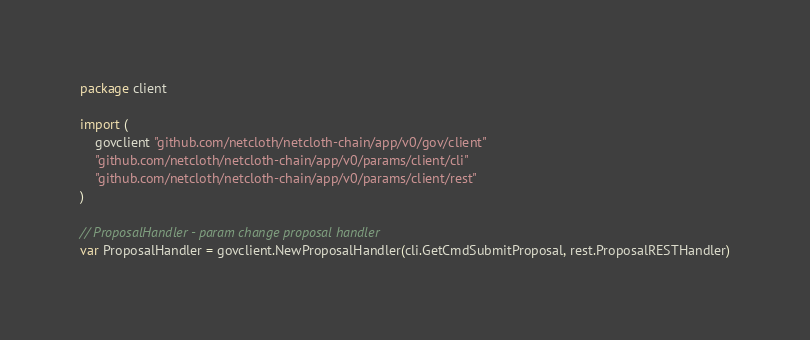Convert code to text. <code><loc_0><loc_0><loc_500><loc_500><_Go_>package client

import (
	govclient "github.com/netcloth/netcloth-chain/app/v0/gov/client"
	"github.com/netcloth/netcloth-chain/app/v0/params/client/cli"
	"github.com/netcloth/netcloth-chain/app/v0/params/client/rest"
)

// ProposalHandler - param change proposal handler
var ProposalHandler = govclient.NewProposalHandler(cli.GetCmdSubmitProposal, rest.ProposalRESTHandler)
</code> 